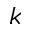Convert formula to latex. <formula><loc_0><loc_0><loc_500><loc_500>k</formula> 